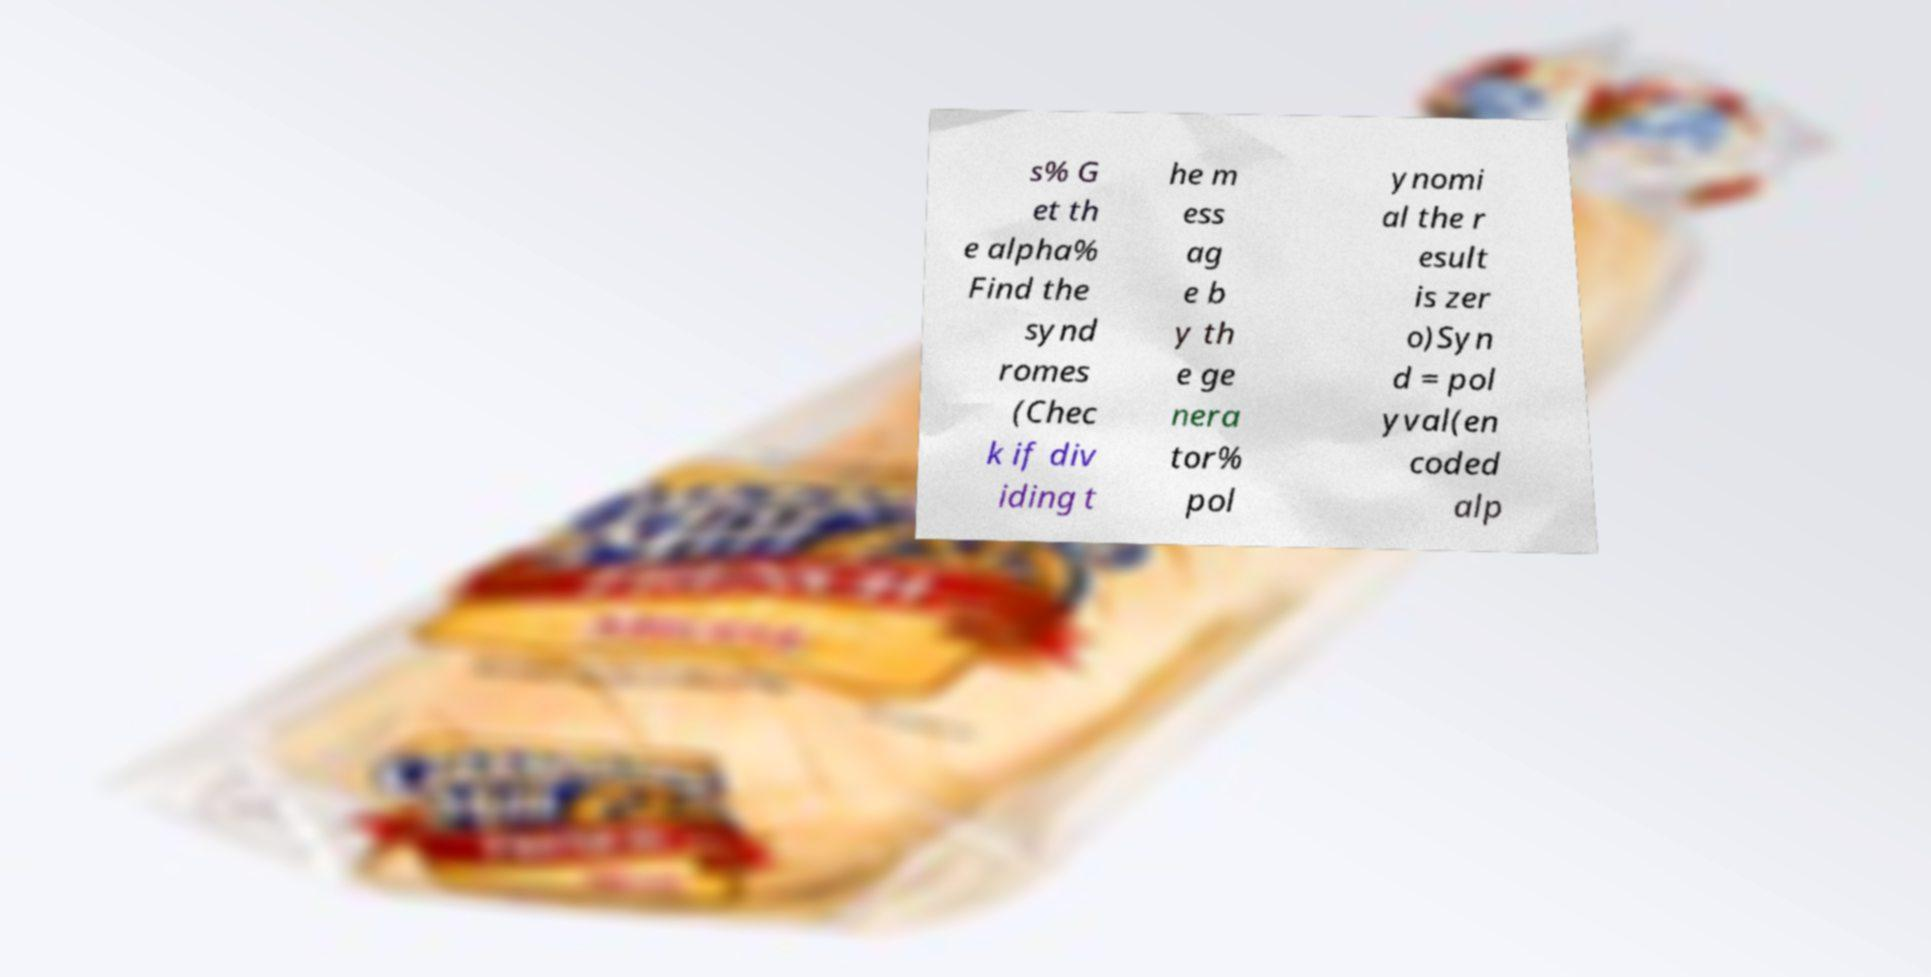I need the written content from this picture converted into text. Can you do that? s% G et th e alpha% Find the synd romes (Chec k if div iding t he m ess ag e b y th e ge nera tor% pol ynomi al the r esult is zer o)Syn d = pol yval(en coded alp 